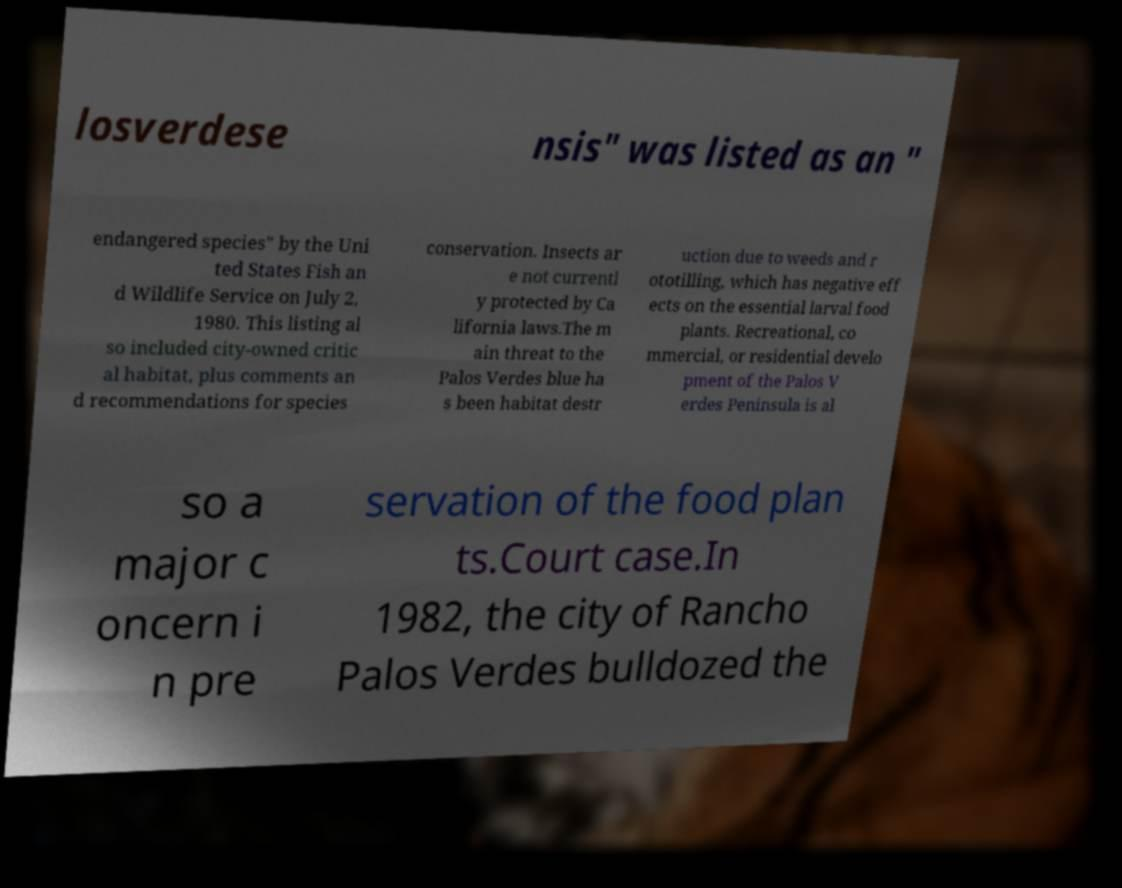Please identify and transcribe the text found in this image. losverdese nsis" was listed as an " endangered species" by the Uni ted States Fish an d Wildlife Service on July 2, 1980. This listing al so included city-owned critic al habitat, plus comments an d recommendations for species conservation. Insects ar e not currentl y protected by Ca lifornia laws.The m ain threat to the Palos Verdes blue ha s been habitat destr uction due to weeds and r ototilling, which has negative eff ects on the essential larval food plants. Recreational, co mmercial, or residential develo pment of the Palos V erdes Peninsula is al so a major c oncern i n pre servation of the food plan ts.Court case.In 1982, the city of Rancho Palos Verdes bulldozed the 